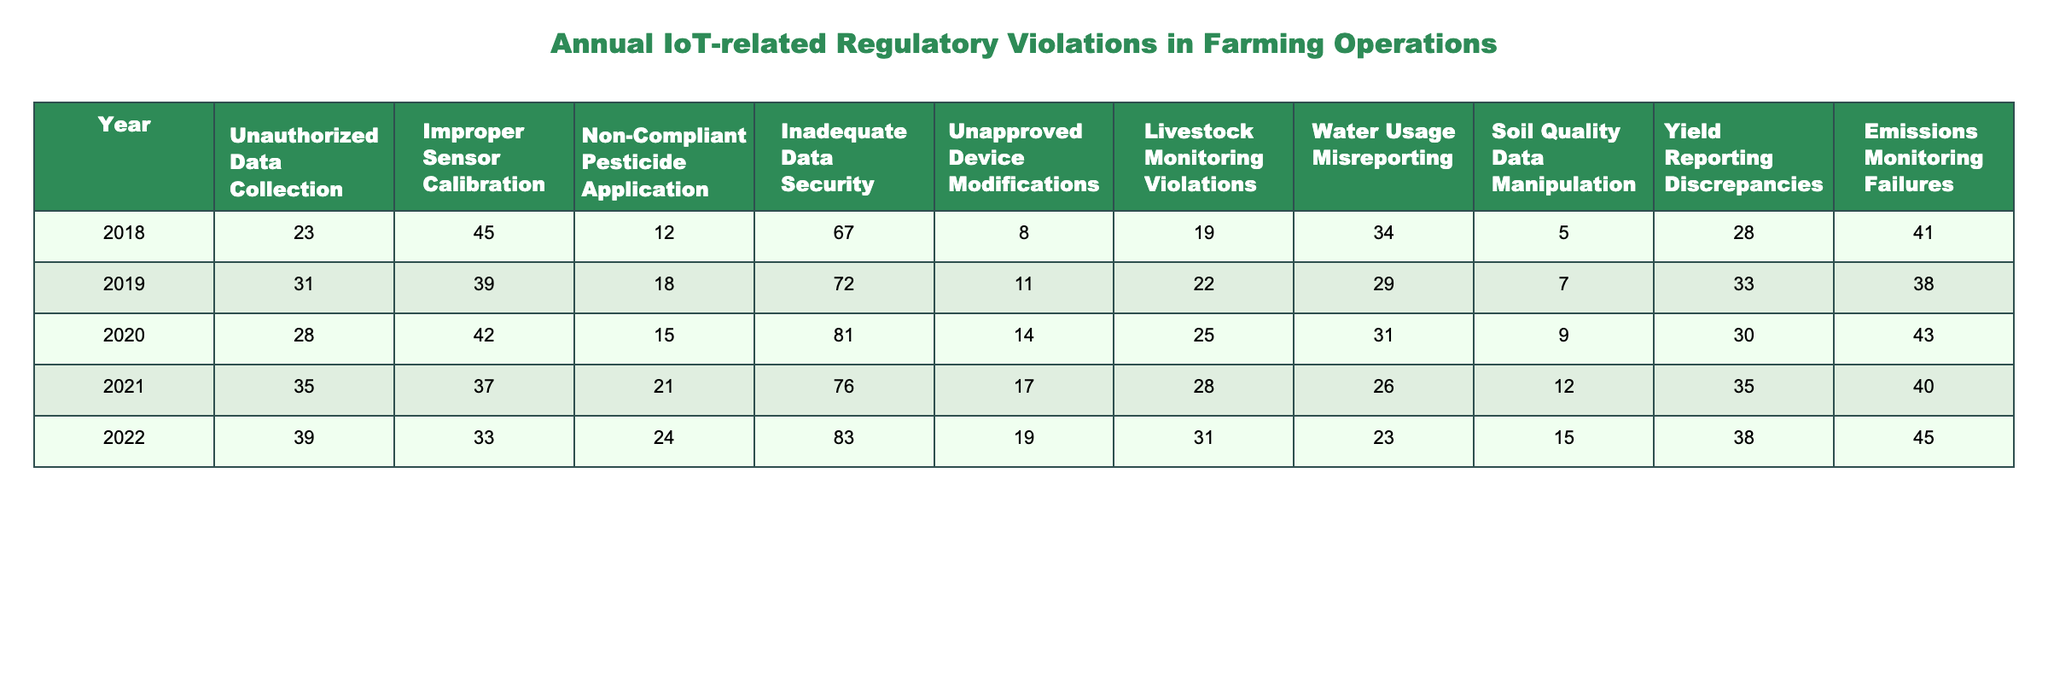What was the highest number of Unauthorized Data Collection violations recorded? The maximum value for Unauthorized Data Collection is found by looking through the list of values for each year, which shows a high of 39 violations in 2022.
Answer: 39 In which year were the fewest Non-Compliant Pesticide Application violations recorded? By reviewing the values for Non-Compliant Pesticide Application, the year with the least number is 12 violations in 2018.
Answer: 12 What is the total number of Improper Sensor Calibration violations from 2018 to 2022? Summing the values gives: 45 + 39 + 42 + 37 + 33 = 196.
Answer: 196 What is the difference in Inadequate Data Security violations between 2020 and 2019? 81 (2020) - 72 (2019) = 9, indicating that there were more violations in 2020 compared to 2019.
Answer: 9 In which year did Livestock Monitoring Violations peak? By locating the maximum for Livestock Monitoring Violations, 31 violations were recorded in 2022, which is the highest.
Answer: 2022 How many years had Unauthorized Data Collection violations over 30? The years with values over 30 are 2019, 2020, 2021, and 2022 which totals 4 years.
Answer: 4 What is the average number of Emissions Monitoring Failures across all five years? Adding the values: 41 + 38 + 43 + 40 + 45 = 207, then dividing by 5 gives an average of 41.4.
Answer: 41.4 Was there a year when Soil Quality Data Manipulation violations were less than 10? There were no years with less than 10 violations in Soil Quality Data Manipulation; the lowest is 5 in 2018.
Answer: No Which type of violation had the highest average count from 2018 to 2022? Calculating the averages, we find the highest average is from Improper Sensor Calibration: (45 + 39 + 42 + 37 + 33) / 5 = 39.2.
Answer: Improper Sensor Calibration In which year was there an increase in Water Usage Misreporting compared to the previous year? Looking at the values, we see an increase from 29 in 2019 to 31 in 2020, indicating an increase.
Answer: 2020 